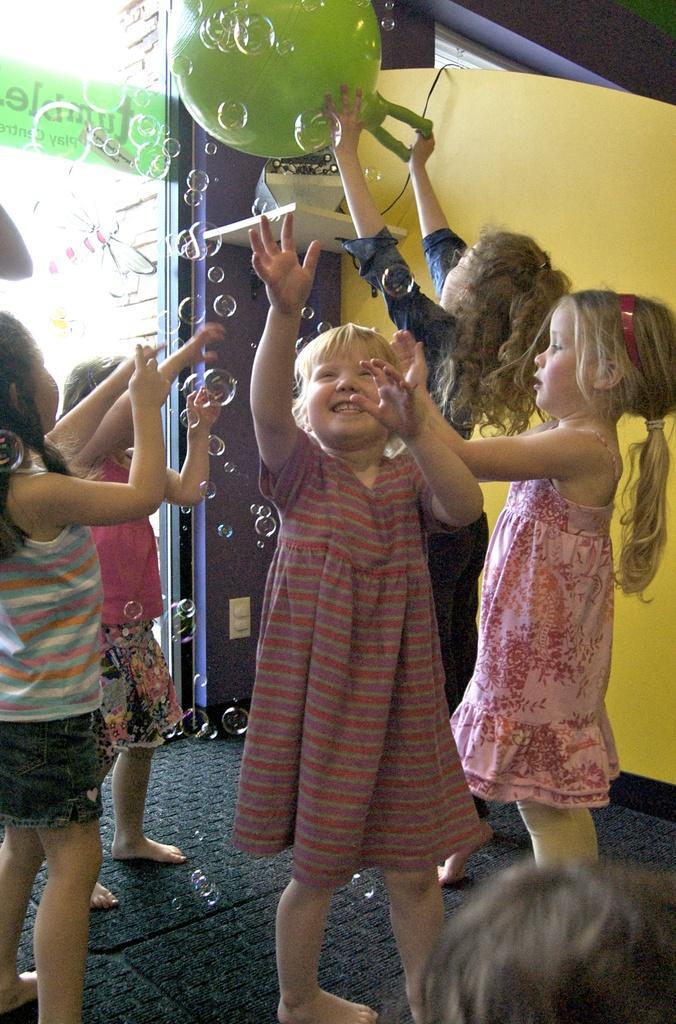Please provide a concise description of this image. In this image, I can see five kids standing on the floor and playing with the soap bubbles. Among them one girl is holding a toy. In the background there is a banner and few objects. 